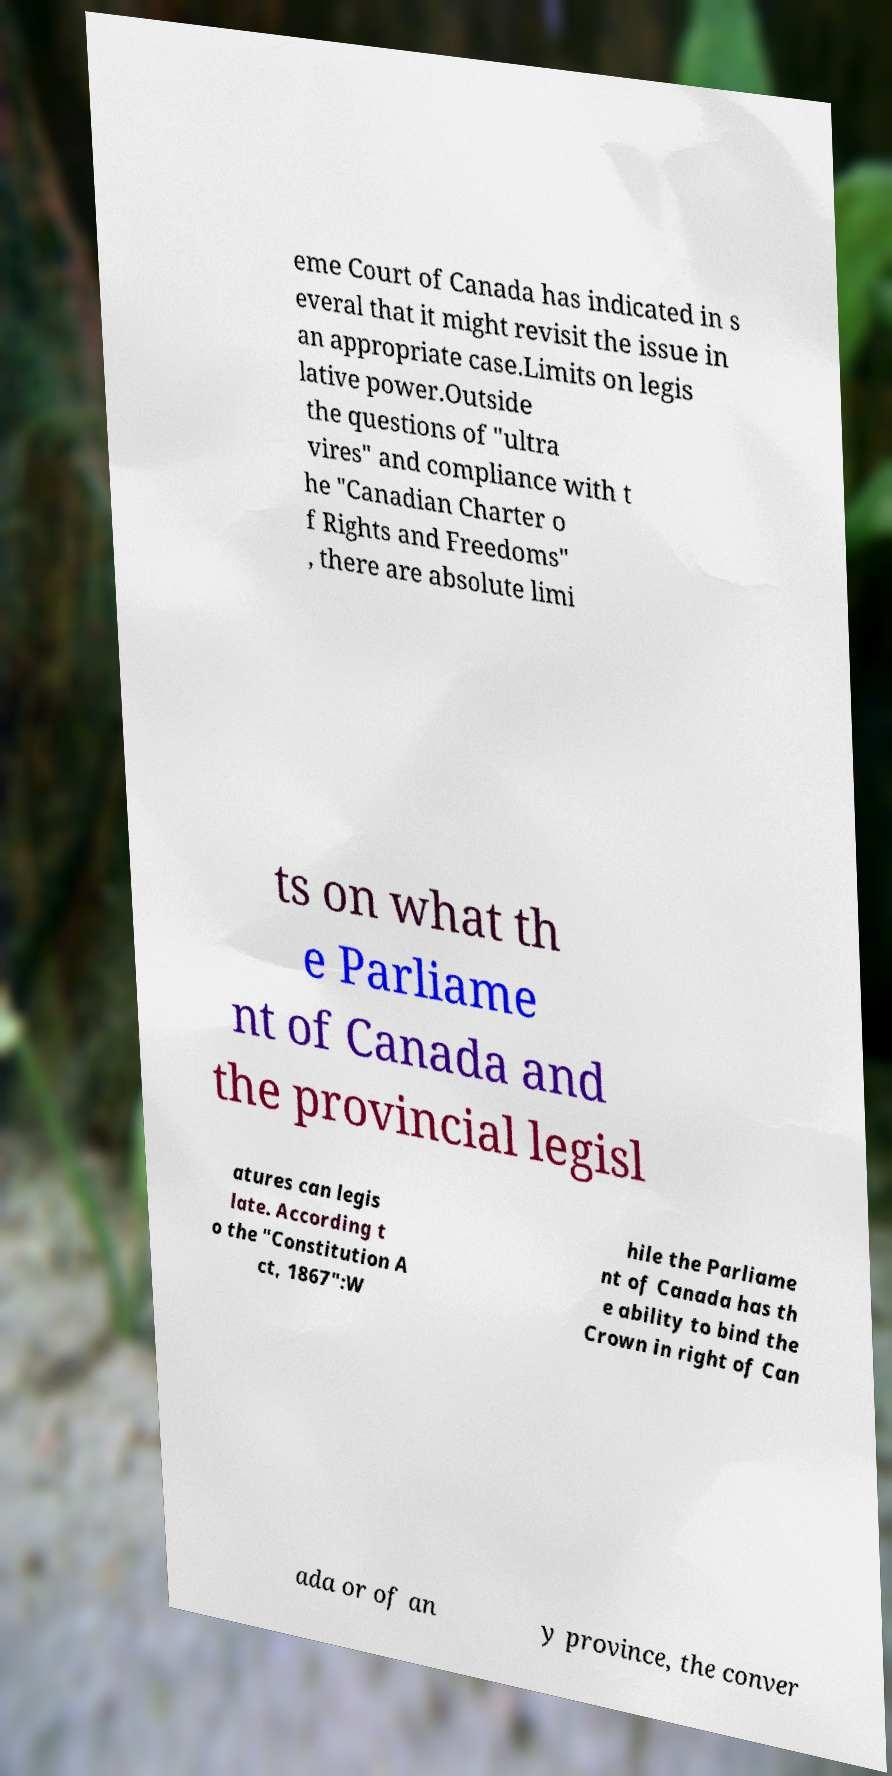For documentation purposes, I need the text within this image transcribed. Could you provide that? eme Court of Canada has indicated in s everal that it might revisit the issue in an appropriate case.Limits on legis lative power.Outside the questions of "ultra vires" and compliance with t he "Canadian Charter o f Rights and Freedoms" , there are absolute limi ts on what th e Parliame nt of Canada and the provincial legisl atures can legis late. According t o the "Constitution A ct, 1867":W hile the Parliame nt of Canada has th e ability to bind the Crown in right of Can ada or of an y province, the conver 